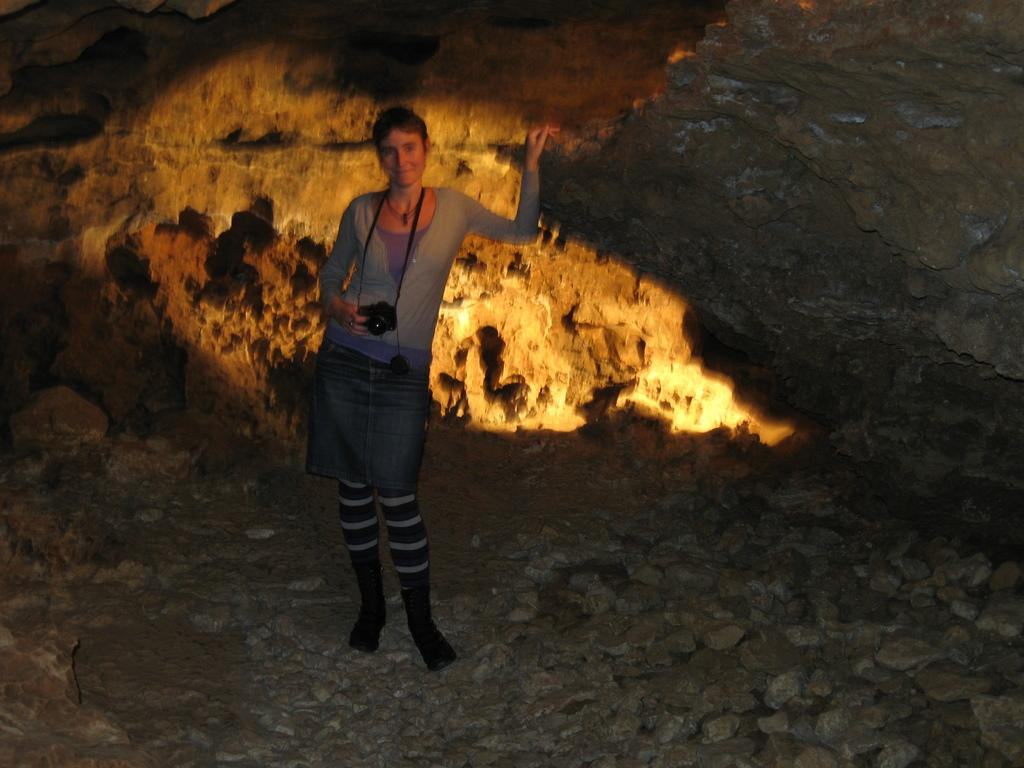Who is the main subject in the image? There is a woman in the image. What is the woman doing in the image? The woman is standing on the ground and holding a camera. What type of objects can be seen in the image? There are rocks and stones in the image. What type of society is depicted in the image? There is no depiction of a society in the image; it features a woman standing on the ground and holding a camera, along with rocks and stones. What channel is the woman watching in the image? There is no television or channel present in the image; it only shows a woman holding a camera and standing on the ground, with rocks and stones nearby. 